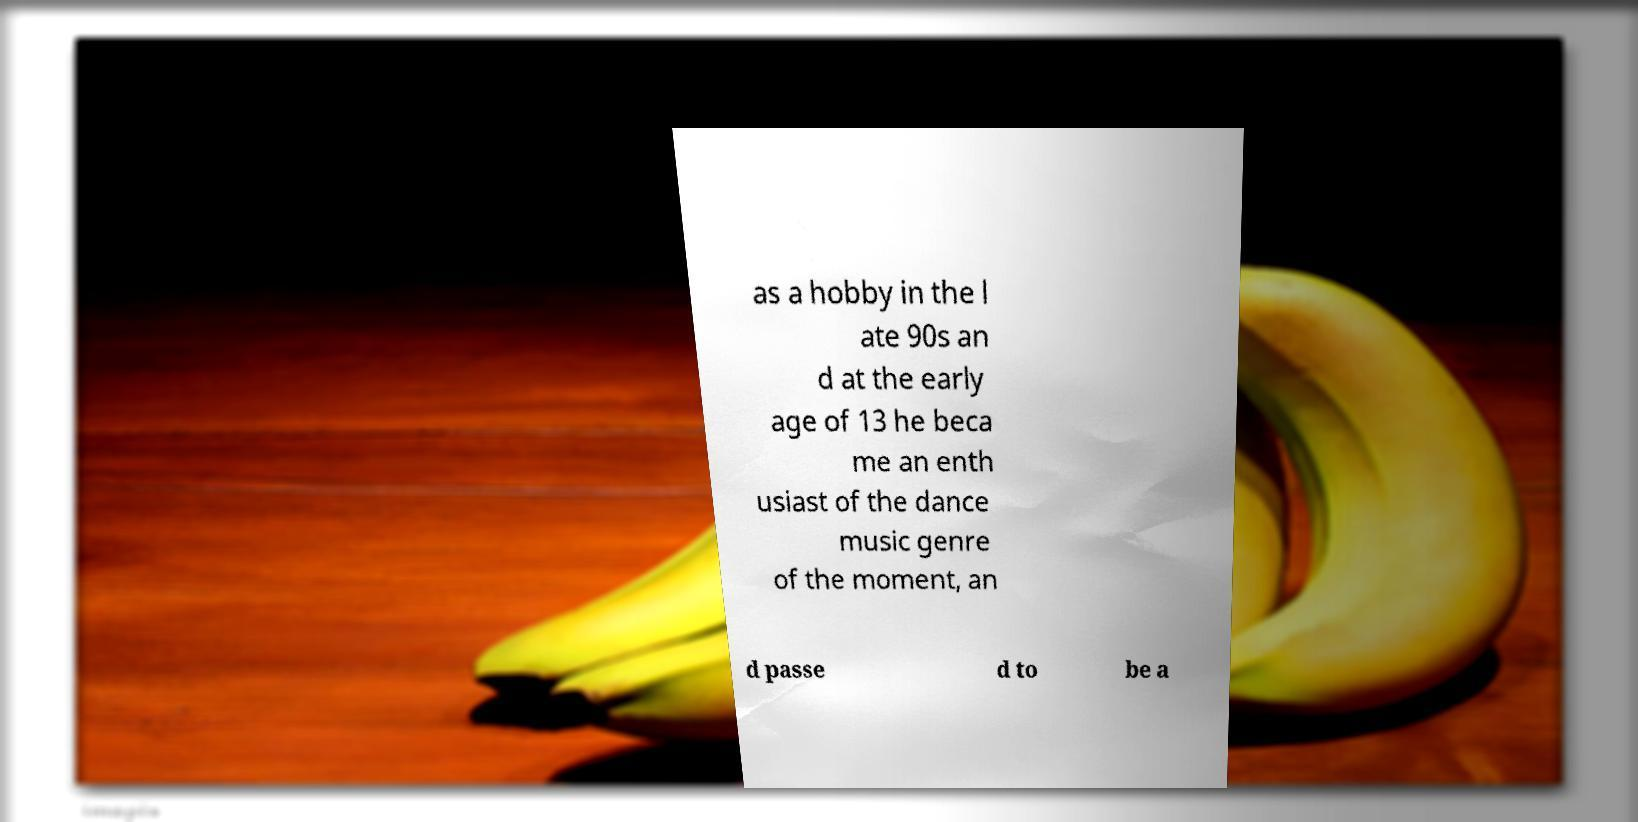I need the written content from this picture converted into text. Can you do that? as a hobby in the l ate 90s an d at the early age of 13 he beca me an enth usiast of the dance music genre of the moment, an d passe d to be a 